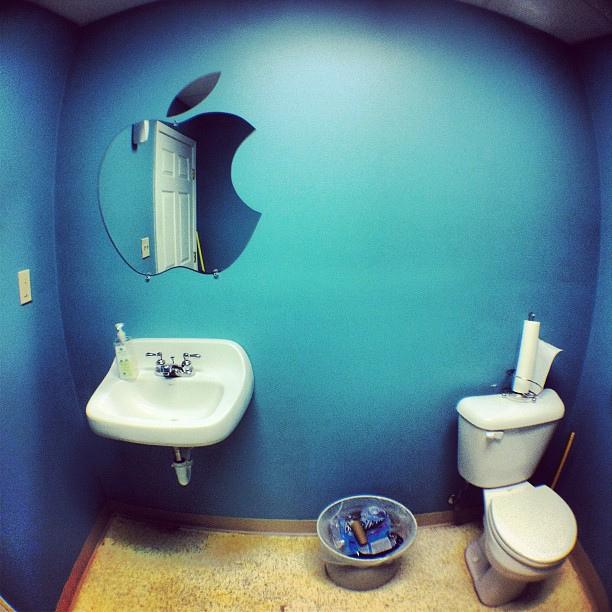What is the main color theme of the bathroom?
Short answer required. Blue. What is the darkest color in this room?
Short answer required. Blue. What room is pictured?
Be succinct. Bathroom. What is in the shape of an apple?
Be succinct. Mirror. 